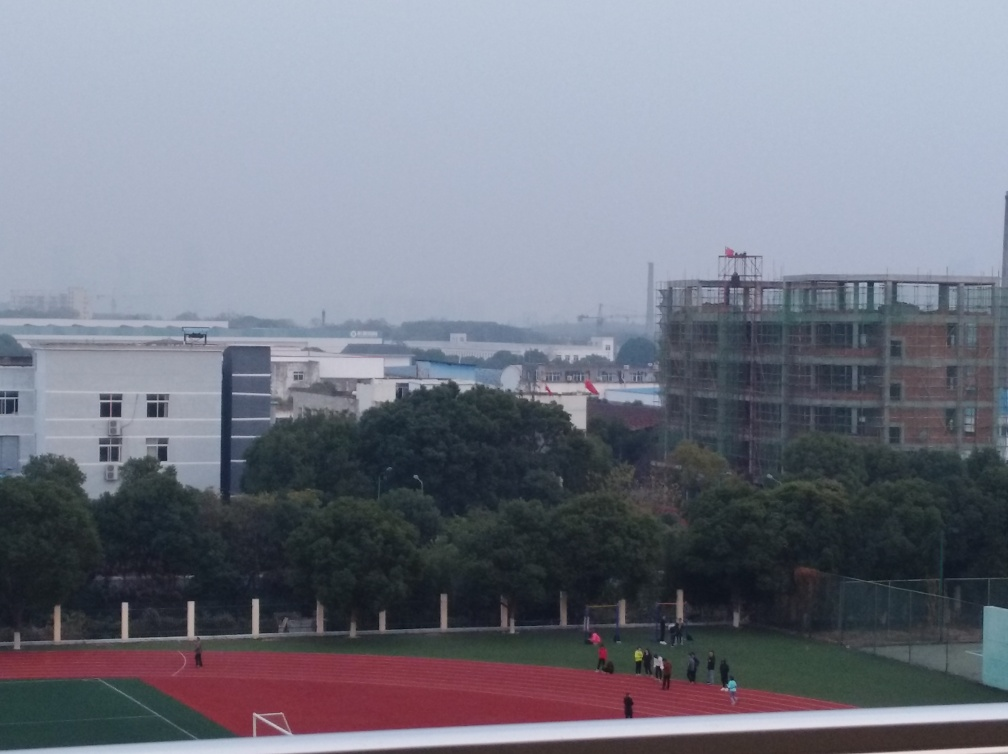Can you describe the activities happening on the sports field? Certainly! There appears to be a group of individuals gathered on the sports field, potentially engaging in various physical activities or sports practice. Some may be walking, while others might be participating in exercises or small-group games. 